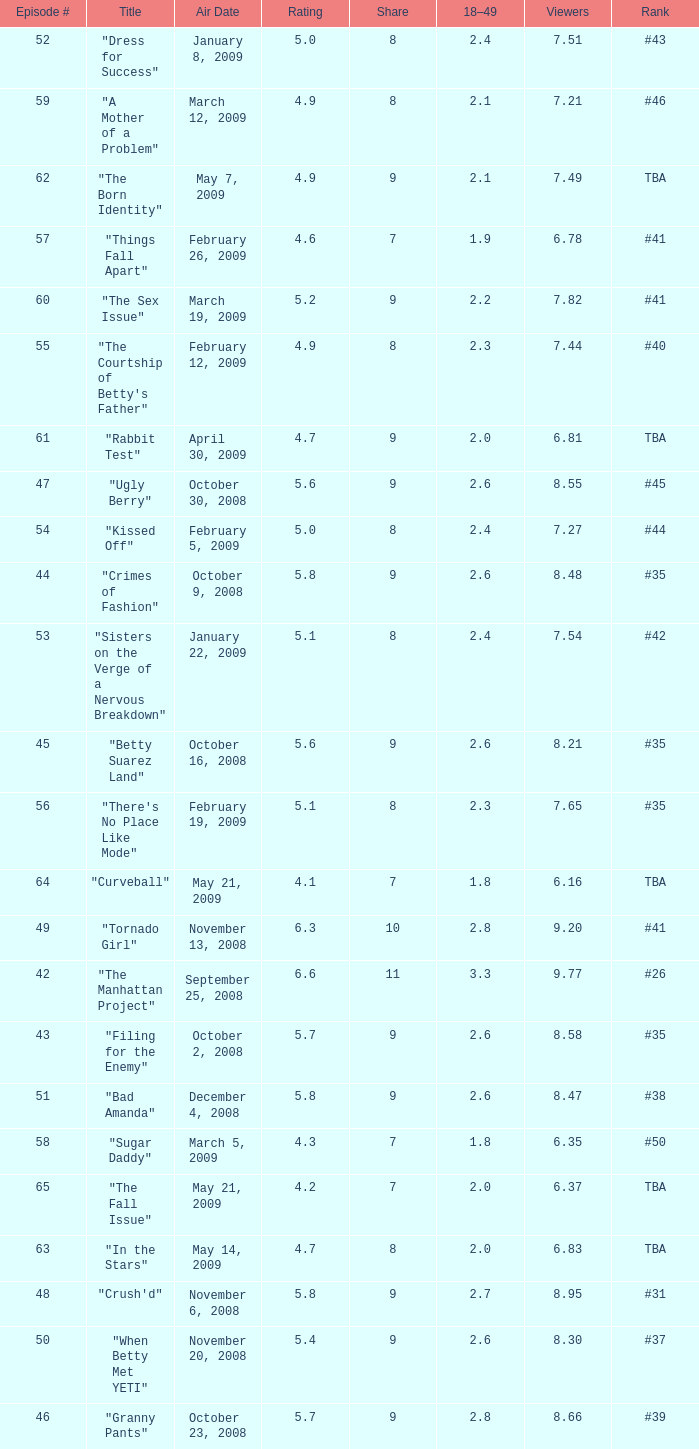What is the total number of Viewers when the rank is #40? 1.0. Could you parse the entire table? {'header': ['Episode #', 'Title', 'Air Date', 'Rating', 'Share', '18–49', 'Viewers', 'Rank'], 'rows': [['52', '"Dress for Success"', 'January 8, 2009', '5.0', '8', '2.4', '7.51', '#43'], ['59', '"A Mother of a Problem"', 'March 12, 2009', '4.9', '8', '2.1', '7.21', '#46'], ['62', '"The Born Identity"', 'May 7, 2009', '4.9', '9', '2.1', '7.49', 'TBA'], ['57', '"Things Fall Apart"', 'February 26, 2009', '4.6', '7', '1.9', '6.78', '#41'], ['60', '"The Sex Issue"', 'March 19, 2009', '5.2', '9', '2.2', '7.82', '#41'], ['55', '"The Courtship of Betty\'s Father"', 'February 12, 2009', '4.9', '8', '2.3', '7.44', '#40'], ['61', '"Rabbit Test"', 'April 30, 2009', '4.7', '9', '2.0', '6.81', 'TBA'], ['47', '"Ugly Berry"', 'October 30, 2008', '5.6', '9', '2.6', '8.55', '#45'], ['54', '"Kissed Off"', 'February 5, 2009', '5.0', '8', '2.4', '7.27', '#44'], ['44', '"Crimes of Fashion"', 'October 9, 2008', '5.8', '9', '2.6', '8.48', '#35'], ['53', '"Sisters on the Verge of a Nervous Breakdown"', 'January 22, 2009', '5.1', '8', '2.4', '7.54', '#42'], ['45', '"Betty Suarez Land"', 'October 16, 2008', '5.6', '9', '2.6', '8.21', '#35'], ['56', '"There\'s No Place Like Mode"', 'February 19, 2009', '5.1', '8', '2.3', '7.65', '#35'], ['64', '"Curveball"', 'May 21, 2009', '4.1', '7', '1.8', '6.16', 'TBA'], ['49', '"Tornado Girl"', 'November 13, 2008', '6.3', '10', '2.8', '9.20', '#41'], ['42', '"The Manhattan Project"', 'September 25, 2008', '6.6', '11', '3.3', '9.77', '#26'], ['43', '"Filing for the Enemy"', 'October 2, 2008', '5.7', '9', '2.6', '8.58', '#35'], ['51', '"Bad Amanda"', 'December 4, 2008', '5.8', '9', '2.6', '8.47', '#38'], ['58', '"Sugar Daddy"', 'March 5, 2009', '4.3', '7', '1.8', '6.35', '#50'], ['65', '"The Fall Issue"', 'May 21, 2009', '4.2', '7', '2.0', '6.37', 'TBA'], ['63', '"In the Stars"', 'May 14, 2009', '4.7', '8', '2.0', '6.83', 'TBA'], ['48', '"Crush\'d"', 'November 6, 2008', '5.8', '9', '2.7', '8.95', '#31'], ['50', '"When Betty Met YETI"', 'November 20, 2008', '5.4', '9', '2.6', '8.30', '#37'], ['46', '"Granny Pants"', 'October 23, 2008', '5.7', '9', '2.8', '8.66', '#39']]} 